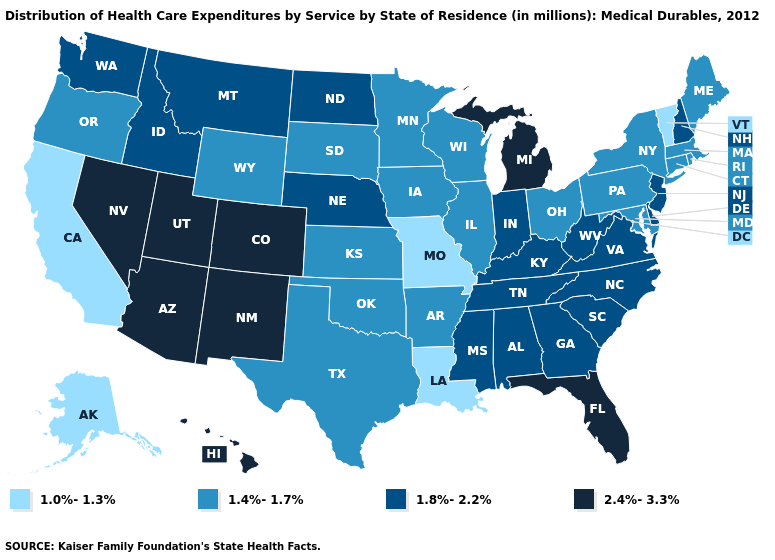Does Minnesota have the lowest value in the MidWest?
Answer briefly. No. Among the states that border Oklahoma , which have the highest value?
Be succinct. Colorado, New Mexico. What is the value of Mississippi?
Give a very brief answer. 1.8%-2.2%. Which states have the lowest value in the Northeast?
Be succinct. Vermont. What is the highest value in the MidWest ?
Write a very short answer. 2.4%-3.3%. What is the value of Arkansas?
Short answer required. 1.4%-1.7%. Which states hav the highest value in the South?
Answer briefly. Florida. What is the value of Alaska?
Keep it brief. 1.0%-1.3%. What is the highest value in states that border Delaware?
Quick response, please. 1.8%-2.2%. Does New Mexico have a higher value than West Virginia?
Quick response, please. Yes. What is the value of Georgia?
Quick response, please. 1.8%-2.2%. What is the highest value in the South ?
Write a very short answer. 2.4%-3.3%. Name the states that have a value in the range 1.0%-1.3%?
Write a very short answer. Alaska, California, Louisiana, Missouri, Vermont. Does New Hampshire have the highest value in the Northeast?
Answer briefly. Yes. What is the value of Hawaii?
Be succinct. 2.4%-3.3%. 